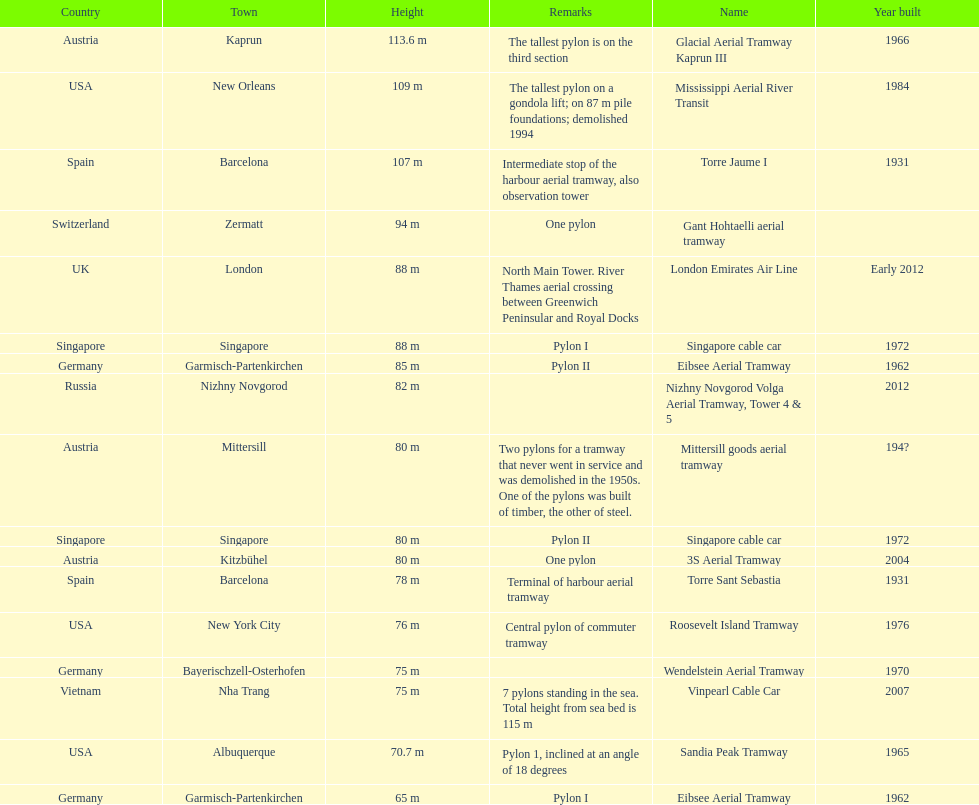How many metres is the mississippi aerial river transit from bottom to top? 109 m. 